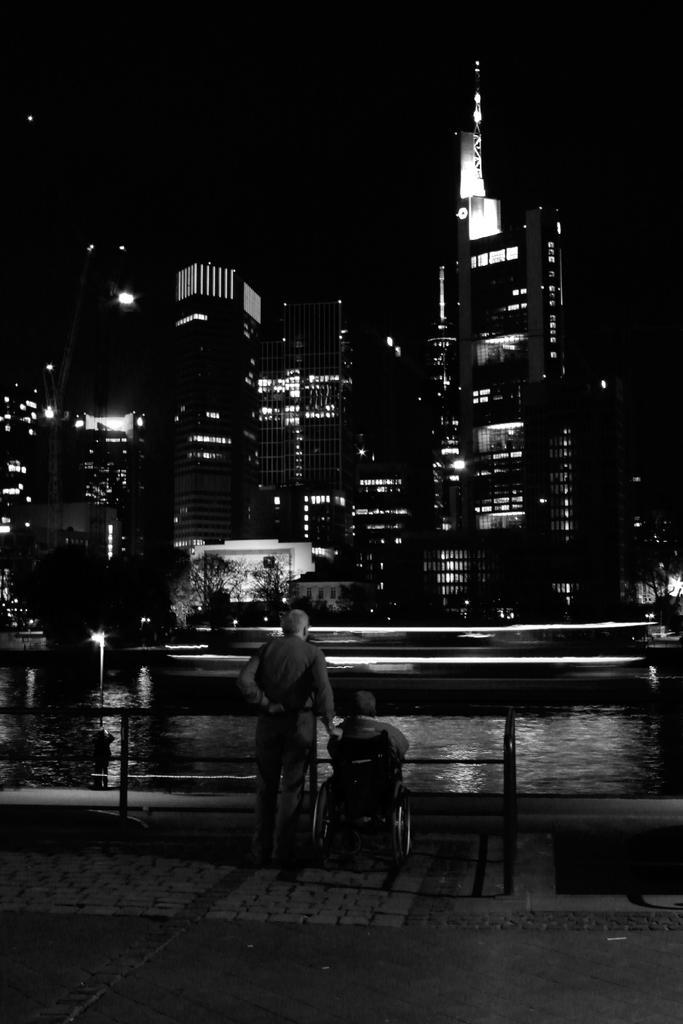Could you give a brief overview of what you see in this image? In this picture we can see so many buildings, in front we can see the water lake, side we can see two people are watching. 